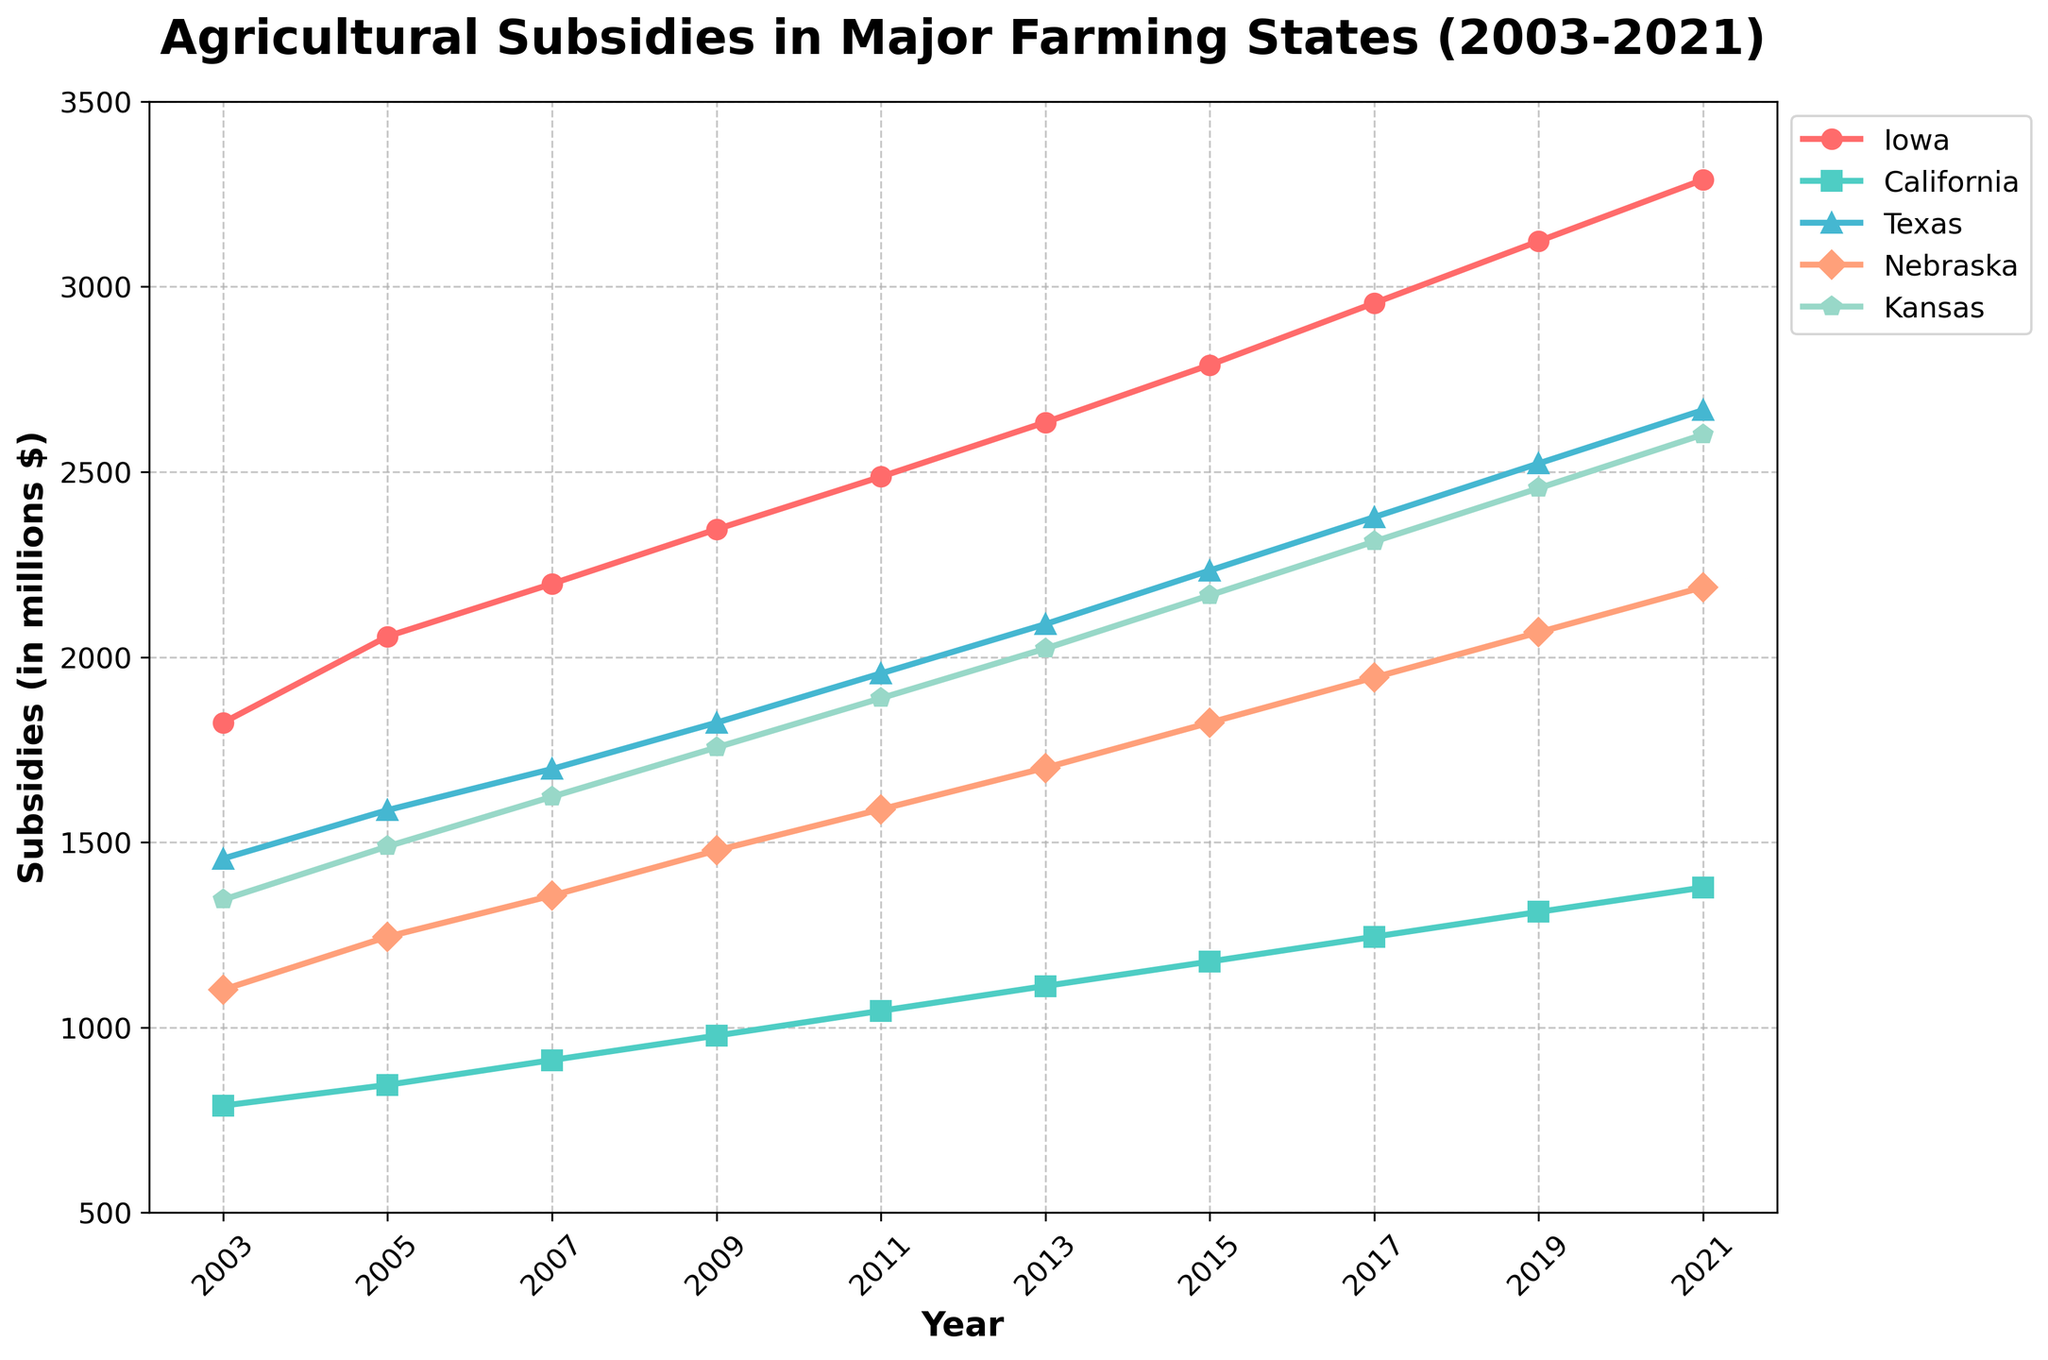What's the trend of subsidies in Iowa from 2003 to 2021? The figure shows that subsidies in Iowa are consistently increasing from 2003 to 2021. Specifically, they rise from 1823 million dollars in 2003 to 3289 million dollars in 2021.
Answer: Increasing Which state had the highest subsidies in 2021? Looking at the endpoint of each line for the year 2021, Iowa has the highest subsidy value at 3289 million dollars.
Answer: Iowa In 2007, which state had higher subsidies: Nebraska or Kansas? Refer to the values of Nebraska and Kansas in 2007. Nebraska's subsidies are 1356 million dollars while Kansas's subsidies are 1623 million dollars, meaning Kansas has higher subsidies.
Answer: Kansas What is the average subsidy amount in Texas over the 20 years? Sum the subsidy values for Texas from 2003 to 2021 and then divide by the number of years (10). (1456 + 1587 + 1698 + 1823 + 1956 + 2089 + 2234 + 2378 + 2523 + 2667) / 10 = 2041.1
Answer: 2041.1 Which state had the least subsidy amount in 2015? Find the lowest subsidy value in 2015 across all states. California has the lowest subsidy at 1178 million dollars in 2015.
Answer: California Calculate the total subsidies for Kansas from 2003 to 2021. Sum up the subsidy values for Kansas from 2003 to 2021. (1345 + 1489 + 1623 + 1756 + 1889 + 2023 + 2167 + 2312 + 2456 + 2601) = 19661
Answer: 19661 Considering the trends, which state shows the most consistent year-to-year increase in subsidies? Iowa displays the most consistent trend with a steady year-to-year increase without any dips or stagnation in the plotted line from 2003 to 2021.
Answer: Iowa Identify the state indicated by the green line and its corresponding marker shape. The green line represents Iowa, indicated by the shape of a circle. By matching the colors and markers to the legend, Iowa uses the green line with circle markers.
Answer: Iowa, Circle 